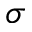Convert formula to latex. <formula><loc_0><loc_0><loc_500><loc_500>\sigma</formula> 